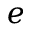Convert formula to latex. <formula><loc_0><loc_0><loc_500><loc_500>e</formula> 